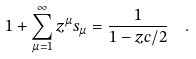<formula> <loc_0><loc_0><loc_500><loc_500>1 + \sum _ { \mu = 1 } ^ { \infty } z ^ { \mu } s _ { \mu } = \frac { 1 } { 1 - z c / 2 } \ \ .</formula> 